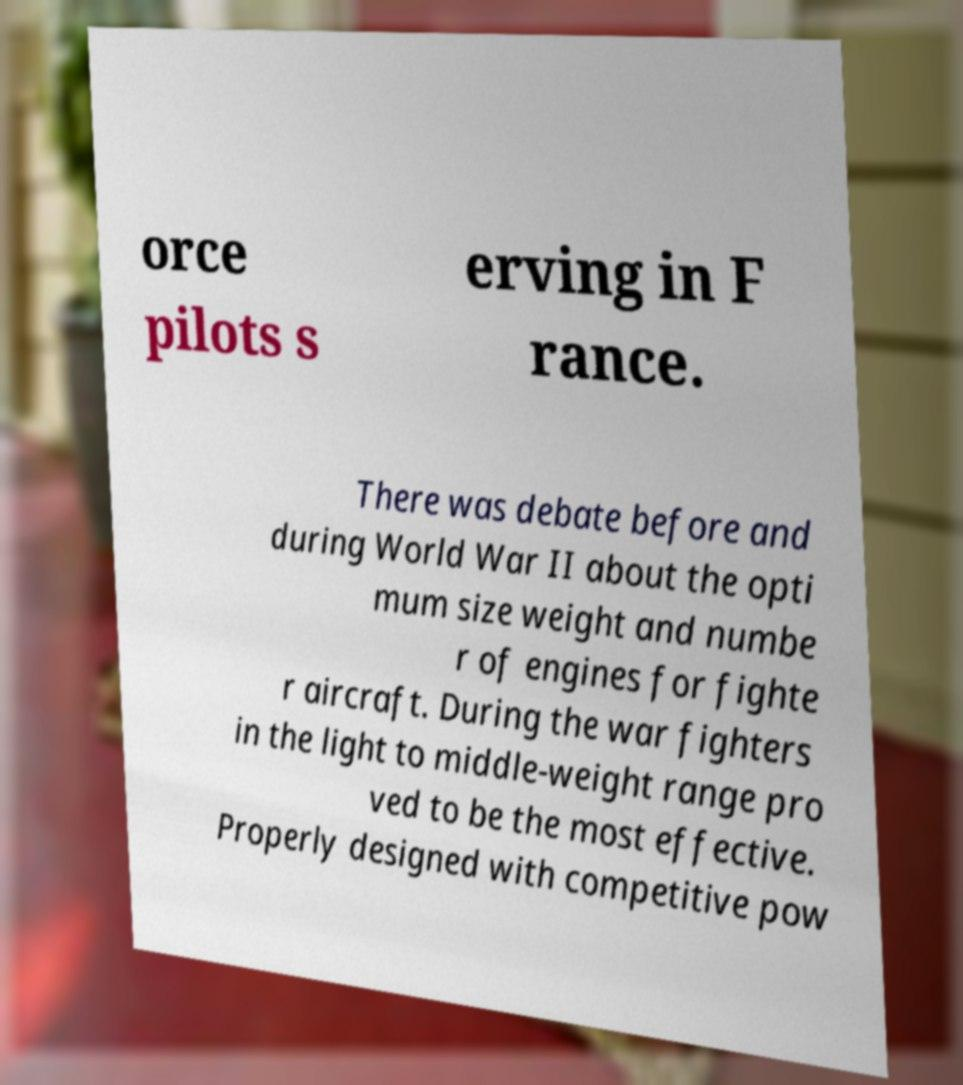Please identify and transcribe the text found in this image. orce pilots s erving in F rance. There was debate before and during World War II about the opti mum size weight and numbe r of engines for fighte r aircraft. During the war fighters in the light to middle-weight range pro ved to be the most effective. Properly designed with competitive pow 